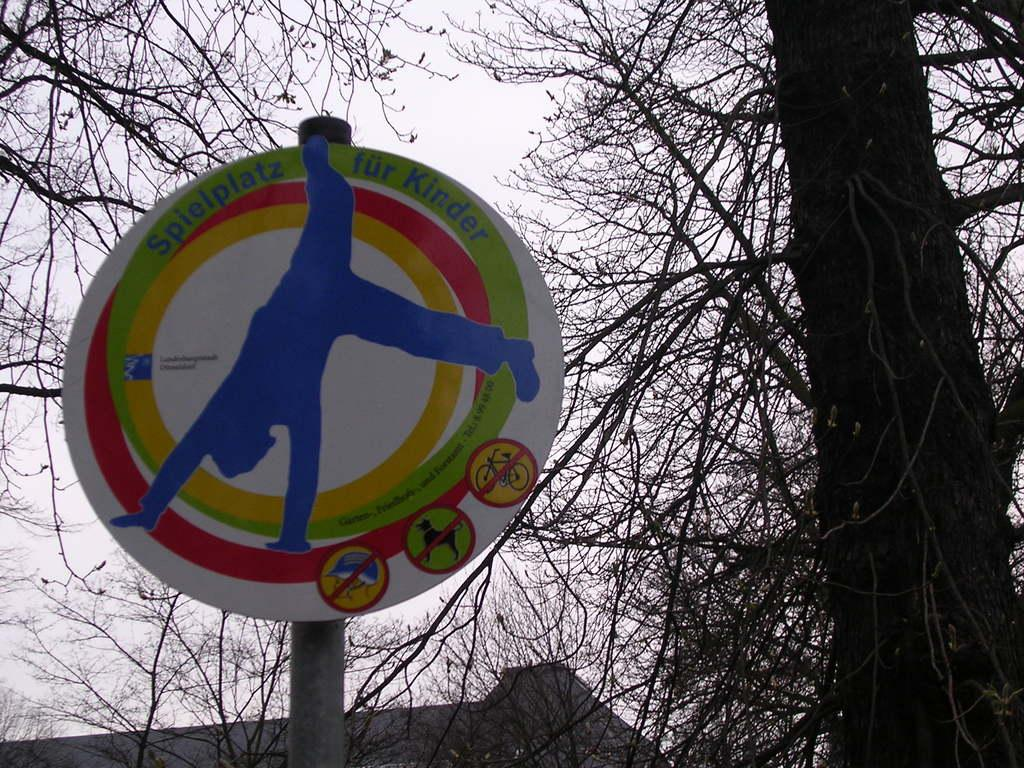What is the main subject in the front of the image? There is a board with text and an image in the front of the image. What can be seen in the background of the image? There are trees and a wall in the background of the image. How would you describe the sky in the image? The sky is cloudy in the image. Can you tell me how many rats are sitting on the board in the image? There are no rats present in the image; the board features text and an image. What type of memory is being used by the board in the image? The board in the image is not a device that uses memory; it is a physical object with text and an image. 